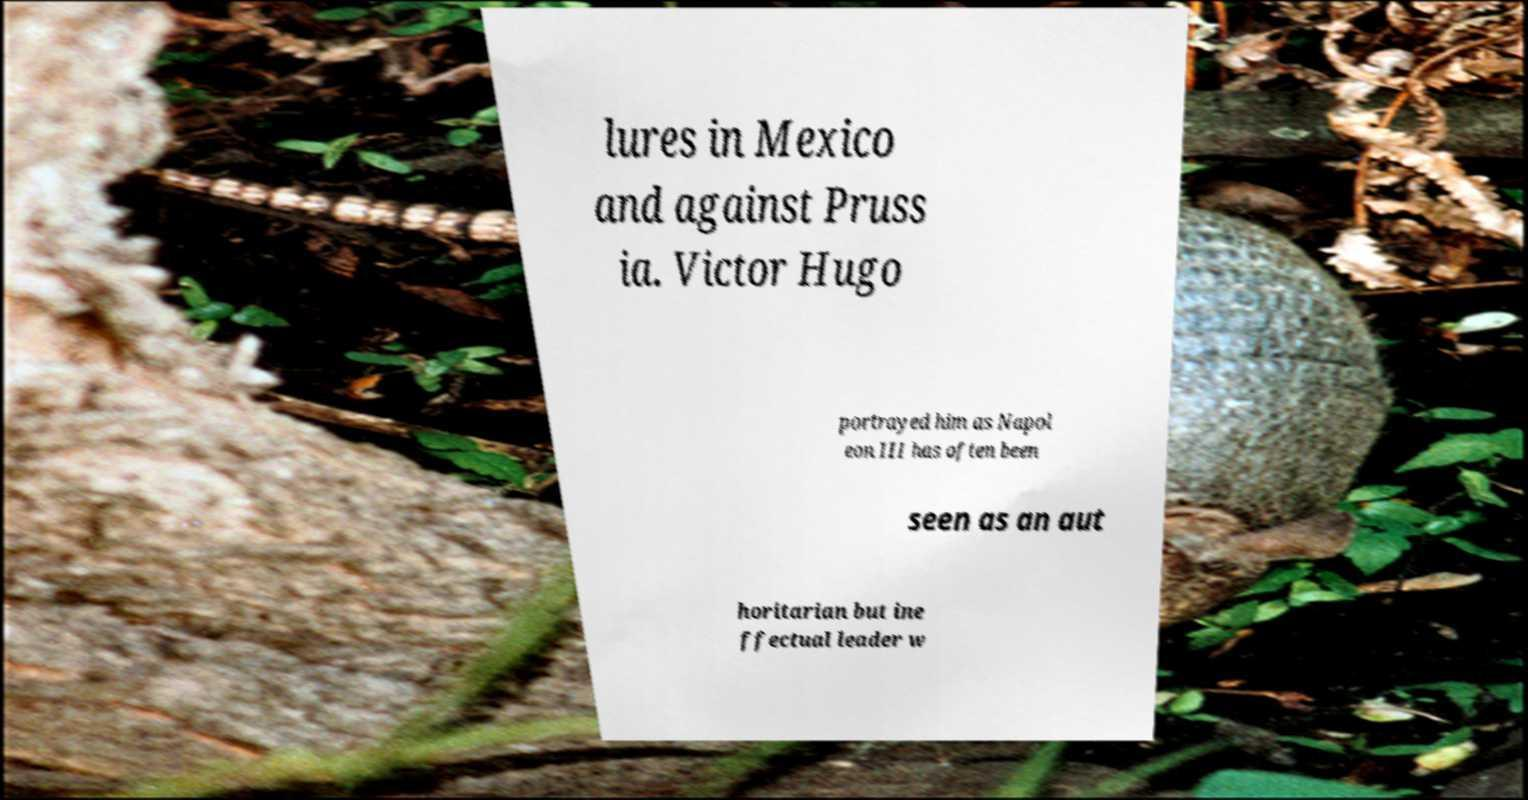What messages or text are displayed in this image? I need them in a readable, typed format. lures in Mexico and against Pruss ia. Victor Hugo portrayed him as Napol eon III has often been seen as an aut horitarian but ine ffectual leader w 